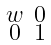Convert formula to latex. <formula><loc_0><loc_0><loc_500><loc_500>\begin{smallmatrix} w & 0 \\ 0 & 1 \end{smallmatrix}</formula> 